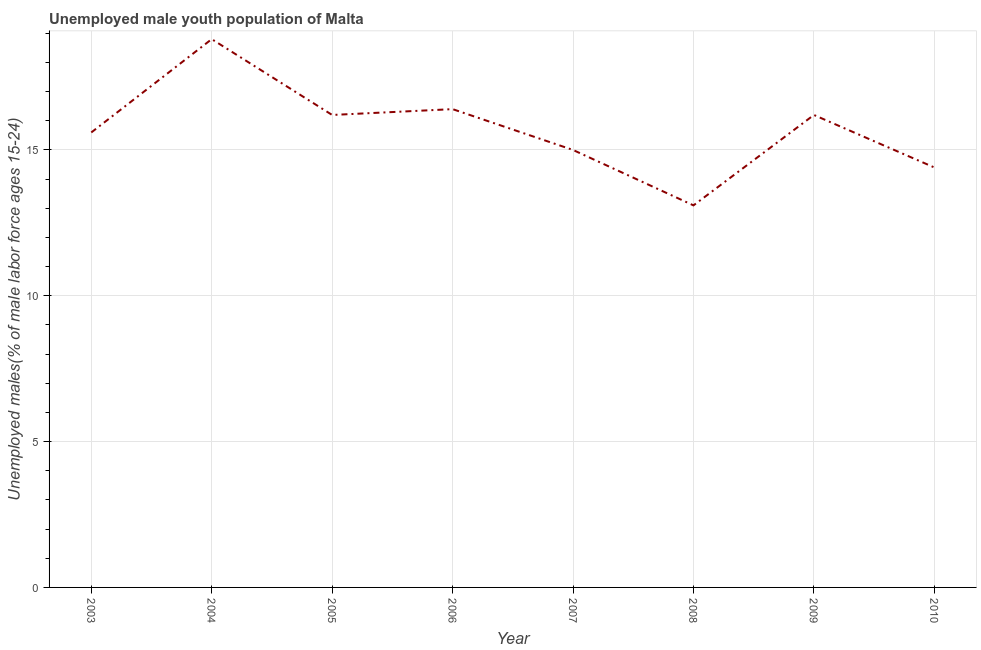What is the unemployed male youth in 2010?
Your answer should be compact. 14.4. Across all years, what is the maximum unemployed male youth?
Provide a succinct answer. 18.8. Across all years, what is the minimum unemployed male youth?
Keep it short and to the point. 13.1. What is the sum of the unemployed male youth?
Provide a succinct answer. 125.7. What is the difference between the unemployed male youth in 2006 and 2010?
Offer a very short reply. 2. What is the average unemployed male youth per year?
Make the answer very short. 15.71. What is the median unemployed male youth?
Your response must be concise. 15.9. Do a majority of the years between 2004 and 2005 (inclusive) have unemployed male youth greater than 16 %?
Your response must be concise. Yes. What is the ratio of the unemployed male youth in 2005 to that in 2010?
Offer a terse response. 1.13. Is the difference between the unemployed male youth in 2003 and 2004 greater than the difference between any two years?
Your response must be concise. No. What is the difference between the highest and the second highest unemployed male youth?
Your response must be concise. 2.4. Is the sum of the unemployed male youth in 2003 and 2010 greater than the maximum unemployed male youth across all years?
Keep it short and to the point. Yes. What is the difference between the highest and the lowest unemployed male youth?
Your response must be concise. 5.7. Does the unemployed male youth monotonically increase over the years?
Provide a succinct answer. No. How many years are there in the graph?
Make the answer very short. 8. Does the graph contain any zero values?
Ensure brevity in your answer.  No. Does the graph contain grids?
Provide a short and direct response. Yes. What is the title of the graph?
Your response must be concise. Unemployed male youth population of Malta. What is the label or title of the Y-axis?
Offer a very short reply. Unemployed males(% of male labor force ages 15-24). What is the Unemployed males(% of male labor force ages 15-24) in 2003?
Provide a succinct answer. 15.6. What is the Unemployed males(% of male labor force ages 15-24) of 2004?
Offer a very short reply. 18.8. What is the Unemployed males(% of male labor force ages 15-24) in 2005?
Your answer should be very brief. 16.2. What is the Unemployed males(% of male labor force ages 15-24) in 2006?
Offer a very short reply. 16.4. What is the Unemployed males(% of male labor force ages 15-24) in 2007?
Your answer should be compact. 15. What is the Unemployed males(% of male labor force ages 15-24) of 2008?
Provide a short and direct response. 13.1. What is the Unemployed males(% of male labor force ages 15-24) in 2009?
Offer a very short reply. 16.2. What is the Unemployed males(% of male labor force ages 15-24) in 2010?
Make the answer very short. 14.4. What is the difference between the Unemployed males(% of male labor force ages 15-24) in 2003 and 2004?
Give a very brief answer. -3.2. What is the difference between the Unemployed males(% of male labor force ages 15-24) in 2003 and 2005?
Ensure brevity in your answer.  -0.6. What is the difference between the Unemployed males(% of male labor force ages 15-24) in 2003 and 2007?
Provide a succinct answer. 0.6. What is the difference between the Unemployed males(% of male labor force ages 15-24) in 2003 and 2008?
Your answer should be compact. 2.5. What is the difference between the Unemployed males(% of male labor force ages 15-24) in 2003 and 2010?
Provide a succinct answer. 1.2. What is the difference between the Unemployed males(% of male labor force ages 15-24) in 2004 and 2006?
Offer a terse response. 2.4. What is the difference between the Unemployed males(% of male labor force ages 15-24) in 2004 and 2009?
Ensure brevity in your answer.  2.6. What is the difference between the Unemployed males(% of male labor force ages 15-24) in 2005 and 2007?
Give a very brief answer. 1.2. What is the difference between the Unemployed males(% of male labor force ages 15-24) in 2005 and 2008?
Provide a short and direct response. 3.1. What is the difference between the Unemployed males(% of male labor force ages 15-24) in 2005 and 2010?
Keep it short and to the point. 1.8. What is the difference between the Unemployed males(% of male labor force ages 15-24) in 2006 and 2007?
Ensure brevity in your answer.  1.4. What is the difference between the Unemployed males(% of male labor force ages 15-24) in 2007 and 2009?
Provide a short and direct response. -1.2. What is the ratio of the Unemployed males(% of male labor force ages 15-24) in 2003 to that in 2004?
Your response must be concise. 0.83. What is the ratio of the Unemployed males(% of male labor force ages 15-24) in 2003 to that in 2005?
Your answer should be compact. 0.96. What is the ratio of the Unemployed males(% of male labor force ages 15-24) in 2003 to that in 2006?
Offer a very short reply. 0.95. What is the ratio of the Unemployed males(% of male labor force ages 15-24) in 2003 to that in 2007?
Provide a short and direct response. 1.04. What is the ratio of the Unemployed males(% of male labor force ages 15-24) in 2003 to that in 2008?
Your response must be concise. 1.19. What is the ratio of the Unemployed males(% of male labor force ages 15-24) in 2003 to that in 2010?
Ensure brevity in your answer.  1.08. What is the ratio of the Unemployed males(% of male labor force ages 15-24) in 2004 to that in 2005?
Provide a succinct answer. 1.16. What is the ratio of the Unemployed males(% of male labor force ages 15-24) in 2004 to that in 2006?
Your response must be concise. 1.15. What is the ratio of the Unemployed males(% of male labor force ages 15-24) in 2004 to that in 2007?
Your response must be concise. 1.25. What is the ratio of the Unemployed males(% of male labor force ages 15-24) in 2004 to that in 2008?
Make the answer very short. 1.44. What is the ratio of the Unemployed males(% of male labor force ages 15-24) in 2004 to that in 2009?
Offer a terse response. 1.16. What is the ratio of the Unemployed males(% of male labor force ages 15-24) in 2004 to that in 2010?
Provide a short and direct response. 1.31. What is the ratio of the Unemployed males(% of male labor force ages 15-24) in 2005 to that in 2006?
Provide a short and direct response. 0.99. What is the ratio of the Unemployed males(% of male labor force ages 15-24) in 2005 to that in 2007?
Keep it short and to the point. 1.08. What is the ratio of the Unemployed males(% of male labor force ages 15-24) in 2005 to that in 2008?
Keep it short and to the point. 1.24. What is the ratio of the Unemployed males(% of male labor force ages 15-24) in 2005 to that in 2010?
Provide a succinct answer. 1.12. What is the ratio of the Unemployed males(% of male labor force ages 15-24) in 2006 to that in 2007?
Your answer should be compact. 1.09. What is the ratio of the Unemployed males(% of male labor force ages 15-24) in 2006 to that in 2008?
Offer a terse response. 1.25. What is the ratio of the Unemployed males(% of male labor force ages 15-24) in 2006 to that in 2010?
Provide a succinct answer. 1.14. What is the ratio of the Unemployed males(% of male labor force ages 15-24) in 2007 to that in 2008?
Keep it short and to the point. 1.15. What is the ratio of the Unemployed males(% of male labor force ages 15-24) in 2007 to that in 2009?
Offer a terse response. 0.93. What is the ratio of the Unemployed males(% of male labor force ages 15-24) in 2007 to that in 2010?
Ensure brevity in your answer.  1.04. What is the ratio of the Unemployed males(% of male labor force ages 15-24) in 2008 to that in 2009?
Ensure brevity in your answer.  0.81. What is the ratio of the Unemployed males(% of male labor force ages 15-24) in 2008 to that in 2010?
Your response must be concise. 0.91. What is the ratio of the Unemployed males(% of male labor force ages 15-24) in 2009 to that in 2010?
Give a very brief answer. 1.12. 